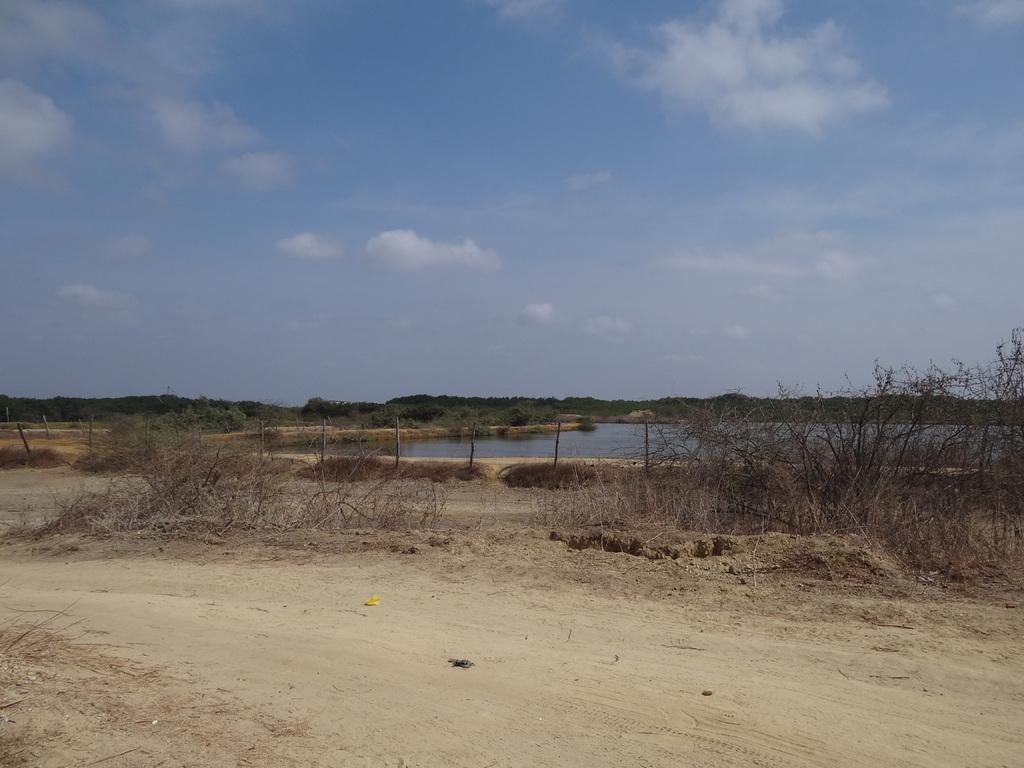What type of living organisms can be seen in the image? Plants and trees are visible in the image. What is the primary element in the image? Water is visible in the image. What type of path can be seen in the image? There is a path in the image. What is visible in the sky in the image? The sky is visible in the image. How many units of cattle can be seen grazing in the image? There are no cattle present in the image. What type of party is being held in the image? There is no party depicted in the image. 